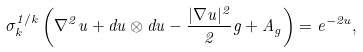<formula> <loc_0><loc_0><loc_500><loc_500>\sigma _ { k } ^ { 1 / k } \left ( \nabla ^ { 2 } u + d u \otimes d u - \frac { | \nabla u | ^ { 2 } } { 2 } g + A _ { g } \right ) = e ^ { - 2 u } ,</formula> 